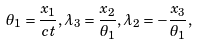Convert formula to latex. <formula><loc_0><loc_0><loc_500><loc_500>\theta _ { 1 } = \frac { x _ { 1 } } { c t } , \lambda _ { 3 } = \frac { x _ { 2 } } { \theta _ { 1 } } , \lambda _ { 2 } = - \frac { x _ { 3 } } { \theta _ { 1 } } ,</formula> 